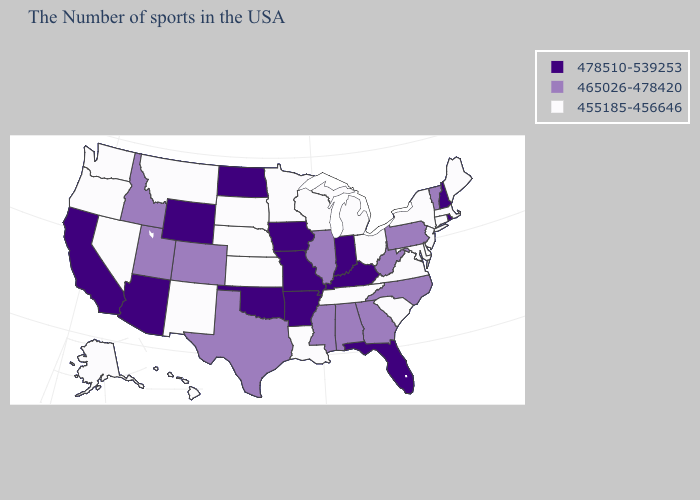What is the highest value in the USA?
Short answer required. 478510-539253. What is the value of Kansas?
Be succinct. 455185-456646. Does Kentucky have the highest value in the USA?
Give a very brief answer. Yes. What is the value of Oregon?
Keep it brief. 455185-456646. Name the states that have a value in the range 478510-539253?
Give a very brief answer. Rhode Island, New Hampshire, Florida, Kentucky, Indiana, Missouri, Arkansas, Iowa, Oklahoma, North Dakota, Wyoming, Arizona, California. Which states have the lowest value in the USA?
Quick response, please. Maine, Massachusetts, Connecticut, New York, New Jersey, Delaware, Maryland, Virginia, South Carolina, Ohio, Michigan, Tennessee, Wisconsin, Louisiana, Minnesota, Kansas, Nebraska, South Dakota, New Mexico, Montana, Nevada, Washington, Oregon, Alaska, Hawaii. Which states have the lowest value in the Northeast?
Give a very brief answer. Maine, Massachusetts, Connecticut, New York, New Jersey. What is the value of Nevada?
Write a very short answer. 455185-456646. What is the highest value in states that border Colorado?
Quick response, please. 478510-539253. Name the states that have a value in the range 465026-478420?
Be succinct. Vermont, Pennsylvania, North Carolina, West Virginia, Georgia, Alabama, Illinois, Mississippi, Texas, Colorado, Utah, Idaho. What is the lowest value in states that border Indiana?
Answer briefly. 455185-456646. Name the states that have a value in the range 478510-539253?
Short answer required. Rhode Island, New Hampshire, Florida, Kentucky, Indiana, Missouri, Arkansas, Iowa, Oklahoma, North Dakota, Wyoming, Arizona, California. Is the legend a continuous bar?
Short answer required. No. Does Rhode Island have the highest value in the USA?
Be succinct. Yes. Is the legend a continuous bar?
Give a very brief answer. No. 